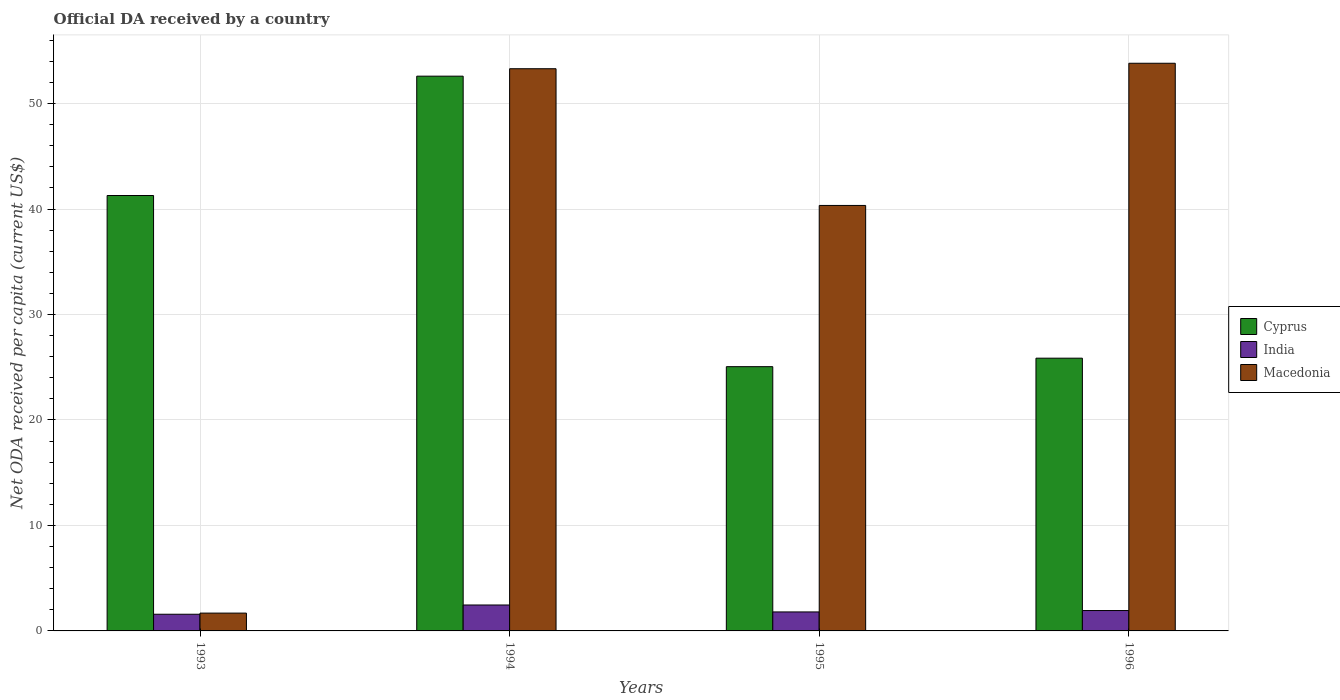How many different coloured bars are there?
Ensure brevity in your answer.  3. Are the number of bars on each tick of the X-axis equal?
Your response must be concise. Yes. How many bars are there on the 3rd tick from the right?
Offer a very short reply. 3. What is the label of the 1st group of bars from the left?
Provide a short and direct response. 1993. In how many cases, is the number of bars for a given year not equal to the number of legend labels?
Your answer should be compact. 0. What is the ODA received in in Macedonia in 1993?
Make the answer very short. 1.69. Across all years, what is the maximum ODA received in in Cyprus?
Ensure brevity in your answer.  52.59. Across all years, what is the minimum ODA received in in Macedonia?
Offer a very short reply. 1.69. What is the total ODA received in in India in the graph?
Your answer should be compact. 7.77. What is the difference between the ODA received in in Macedonia in 1994 and that in 1995?
Ensure brevity in your answer.  12.96. What is the difference between the ODA received in in India in 1993 and the ODA received in in Cyprus in 1996?
Your answer should be compact. -24.28. What is the average ODA received in in Macedonia per year?
Offer a terse response. 37.29. In the year 1994, what is the difference between the ODA received in in India and ODA received in in Cyprus?
Offer a terse response. -50.14. In how many years, is the ODA received in in Macedonia greater than 30 US$?
Provide a short and direct response. 3. What is the ratio of the ODA received in in India in 1993 to that in 1995?
Your response must be concise. 0.88. What is the difference between the highest and the second highest ODA received in in India?
Your answer should be compact. 0.53. What is the difference between the highest and the lowest ODA received in in Macedonia?
Offer a terse response. 52.13. In how many years, is the ODA received in in Cyprus greater than the average ODA received in in Cyprus taken over all years?
Your response must be concise. 2. Is the sum of the ODA received in in Cyprus in 1993 and 1996 greater than the maximum ODA received in in India across all years?
Ensure brevity in your answer.  Yes. What does the 1st bar from the left in 1995 represents?
Provide a succinct answer. Cyprus. Is it the case that in every year, the sum of the ODA received in in Macedonia and ODA received in in Cyprus is greater than the ODA received in in India?
Keep it short and to the point. Yes. How many years are there in the graph?
Keep it short and to the point. 4. Does the graph contain any zero values?
Your response must be concise. No. How many legend labels are there?
Your answer should be compact. 3. How are the legend labels stacked?
Offer a very short reply. Vertical. What is the title of the graph?
Provide a short and direct response. Official DA received by a country. Does "Argentina" appear as one of the legend labels in the graph?
Offer a very short reply. No. What is the label or title of the X-axis?
Make the answer very short. Years. What is the label or title of the Y-axis?
Your answer should be very brief. Net ODA received per capita (current US$). What is the Net ODA received per capita (current US$) of Cyprus in 1993?
Offer a terse response. 41.28. What is the Net ODA received per capita (current US$) of India in 1993?
Ensure brevity in your answer.  1.58. What is the Net ODA received per capita (current US$) of Macedonia in 1993?
Provide a succinct answer. 1.69. What is the Net ODA received per capita (current US$) of Cyprus in 1994?
Your response must be concise. 52.59. What is the Net ODA received per capita (current US$) of India in 1994?
Give a very brief answer. 2.46. What is the Net ODA received per capita (current US$) of Macedonia in 1994?
Your response must be concise. 53.3. What is the Net ODA received per capita (current US$) of Cyprus in 1995?
Provide a succinct answer. 25.05. What is the Net ODA received per capita (current US$) in India in 1995?
Your answer should be very brief. 1.8. What is the Net ODA received per capita (current US$) in Macedonia in 1995?
Your answer should be compact. 40.34. What is the Net ODA received per capita (current US$) in Cyprus in 1996?
Give a very brief answer. 25.86. What is the Net ODA received per capita (current US$) of India in 1996?
Ensure brevity in your answer.  1.93. What is the Net ODA received per capita (current US$) of Macedonia in 1996?
Give a very brief answer. 53.82. Across all years, what is the maximum Net ODA received per capita (current US$) in Cyprus?
Keep it short and to the point. 52.59. Across all years, what is the maximum Net ODA received per capita (current US$) of India?
Offer a terse response. 2.46. Across all years, what is the maximum Net ODA received per capita (current US$) of Macedonia?
Provide a short and direct response. 53.82. Across all years, what is the minimum Net ODA received per capita (current US$) of Cyprus?
Make the answer very short. 25.05. Across all years, what is the minimum Net ODA received per capita (current US$) of India?
Make the answer very short. 1.58. Across all years, what is the minimum Net ODA received per capita (current US$) of Macedonia?
Ensure brevity in your answer.  1.69. What is the total Net ODA received per capita (current US$) of Cyprus in the graph?
Provide a succinct answer. 144.78. What is the total Net ODA received per capita (current US$) in India in the graph?
Offer a terse response. 7.77. What is the total Net ODA received per capita (current US$) in Macedonia in the graph?
Offer a very short reply. 149.14. What is the difference between the Net ODA received per capita (current US$) of Cyprus in 1993 and that in 1994?
Provide a short and direct response. -11.31. What is the difference between the Net ODA received per capita (current US$) of India in 1993 and that in 1994?
Offer a terse response. -0.88. What is the difference between the Net ODA received per capita (current US$) in Macedonia in 1993 and that in 1994?
Provide a succinct answer. -51.61. What is the difference between the Net ODA received per capita (current US$) in Cyprus in 1993 and that in 1995?
Provide a short and direct response. 16.23. What is the difference between the Net ODA received per capita (current US$) in India in 1993 and that in 1995?
Ensure brevity in your answer.  -0.22. What is the difference between the Net ODA received per capita (current US$) of Macedonia in 1993 and that in 1995?
Make the answer very short. -38.65. What is the difference between the Net ODA received per capita (current US$) of Cyprus in 1993 and that in 1996?
Your answer should be compact. 15.42. What is the difference between the Net ODA received per capita (current US$) of India in 1993 and that in 1996?
Ensure brevity in your answer.  -0.35. What is the difference between the Net ODA received per capita (current US$) of Macedonia in 1993 and that in 1996?
Your response must be concise. -52.13. What is the difference between the Net ODA received per capita (current US$) in Cyprus in 1994 and that in 1995?
Ensure brevity in your answer.  27.54. What is the difference between the Net ODA received per capita (current US$) of India in 1994 and that in 1995?
Offer a terse response. 0.66. What is the difference between the Net ODA received per capita (current US$) in Macedonia in 1994 and that in 1995?
Give a very brief answer. 12.96. What is the difference between the Net ODA received per capita (current US$) in Cyprus in 1994 and that in 1996?
Your answer should be compact. 26.74. What is the difference between the Net ODA received per capita (current US$) in India in 1994 and that in 1996?
Provide a short and direct response. 0.53. What is the difference between the Net ODA received per capita (current US$) in Macedonia in 1994 and that in 1996?
Make the answer very short. -0.52. What is the difference between the Net ODA received per capita (current US$) of Cyprus in 1995 and that in 1996?
Keep it short and to the point. -0.8. What is the difference between the Net ODA received per capita (current US$) in India in 1995 and that in 1996?
Offer a very short reply. -0.13. What is the difference between the Net ODA received per capita (current US$) in Macedonia in 1995 and that in 1996?
Your answer should be compact. -13.48. What is the difference between the Net ODA received per capita (current US$) of Cyprus in 1993 and the Net ODA received per capita (current US$) of India in 1994?
Offer a very short reply. 38.82. What is the difference between the Net ODA received per capita (current US$) in Cyprus in 1993 and the Net ODA received per capita (current US$) in Macedonia in 1994?
Your answer should be very brief. -12.02. What is the difference between the Net ODA received per capita (current US$) in India in 1993 and the Net ODA received per capita (current US$) in Macedonia in 1994?
Offer a terse response. -51.72. What is the difference between the Net ODA received per capita (current US$) of Cyprus in 1993 and the Net ODA received per capita (current US$) of India in 1995?
Ensure brevity in your answer.  39.48. What is the difference between the Net ODA received per capita (current US$) of Cyprus in 1993 and the Net ODA received per capita (current US$) of Macedonia in 1995?
Your response must be concise. 0.94. What is the difference between the Net ODA received per capita (current US$) of India in 1993 and the Net ODA received per capita (current US$) of Macedonia in 1995?
Offer a terse response. -38.76. What is the difference between the Net ODA received per capita (current US$) of Cyprus in 1993 and the Net ODA received per capita (current US$) of India in 1996?
Offer a terse response. 39.35. What is the difference between the Net ODA received per capita (current US$) in Cyprus in 1993 and the Net ODA received per capita (current US$) in Macedonia in 1996?
Give a very brief answer. -12.54. What is the difference between the Net ODA received per capita (current US$) of India in 1993 and the Net ODA received per capita (current US$) of Macedonia in 1996?
Provide a succinct answer. -52.24. What is the difference between the Net ODA received per capita (current US$) of Cyprus in 1994 and the Net ODA received per capita (current US$) of India in 1995?
Make the answer very short. 50.79. What is the difference between the Net ODA received per capita (current US$) of Cyprus in 1994 and the Net ODA received per capita (current US$) of Macedonia in 1995?
Ensure brevity in your answer.  12.26. What is the difference between the Net ODA received per capita (current US$) in India in 1994 and the Net ODA received per capita (current US$) in Macedonia in 1995?
Give a very brief answer. -37.88. What is the difference between the Net ODA received per capita (current US$) of Cyprus in 1994 and the Net ODA received per capita (current US$) of India in 1996?
Your answer should be very brief. 50.66. What is the difference between the Net ODA received per capita (current US$) of Cyprus in 1994 and the Net ODA received per capita (current US$) of Macedonia in 1996?
Provide a short and direct response. -1.22. What is the difference between the Net ODA received per capita (current US$) of India in 1994 and the Net ODA received per capita (current US$) of Macedonia in 1996?
Make the answer very short. -51.36. What is the difference between the Net ODA received per capita (current US$) of Cyprus in 1995 and the Net ODA received per capita (current US$) of India in 1996?
Make the answer very short. 23.12. What is the difference between the Net ODA received per capita (current US$) in Cyprus in 1995 and the Net ODA received per capita (current US$) in Macedonia in 1996?
Provide a short and direct response. -28.76. What is the difference between the Net ODA received per capita (current US$) in India in 1995 and the Net ODA received per capita (current US$) in Macedonia in 1996?
Provide a succinct answer. -52.02. What is the average Net ODA received per capita (current US$) in Cyprus per year?
Offer a terse response. 36.2. What is the average Net ODA received per capita (current US$) in India per year?
Provide a succinct answer. 1.94. What is the average Net ODA received per capita (current US$) of Macedonia per year?
Your answer should be very brief. 37.29. In the year 1993, what is the difference between the Net ODA received per capita (current US$) of Cyprus and Net ODA received per capita (current US$) of India?
Your response must be concise. 39.7. In the year 1993, what is the difference between the Net ODA received per capita (current US$) in Cyprus and Net ODA received per capita (current US$) in Macedonia?
Keep it short and to the point. 39.59. In the year 1993, what is the difference between the Net ODA received per capita (current US$) of India and Net ODA received per capita (current US$) of Macedonia?
Offer a terse response. -0.11. In the year 1994, what is the difference between the Net ODA received per capita (current US$) in Cyprus and Net ODA received per capita (current US$) in India?
Offer a terse response. 50.14. In the year 1994, what is the difference between the Net ODA received per capita (current US$) of Cyprus and Net ODA received per capita (current US$) of Macedonia?
Keep it short and to the point. -0.7. In the year 1994, what is the difference between the Net ODA received per capita (current US$) of India and Net ODA received per capita (current US$) of Macedonia?
Your answer should be compact. -50.84. In the year 1995, what is the difference between the Net ODA received per capita (current US$) of Cyprus and Net ODA received per capita (current US$) of India?
Offer a terse response. 23.25. In the year 1995, what is the difference between the Net ODA received per capita (current US$) in Cyprus and Net ODA received per capita (current US$) in Macedonia?
Offer a very short reply. -15.28. In the year 1995, what is the difference between the Net ODA received per capita (current US$) of India and Net ODA received per capita (current US$) of Macedonia?
Your answer should be very brief. -38.54. In the year 1996, what is the difference between the Net ODA received per capita (current US$) in Cyprus and Net ODA received per capita (current US$) in India?
Your answer should be very brief. 23.93. In the year 1996, what is the difference between the Net ODA received per capita (current US$) in Cyprus and Net ODA received per capita (current US$) in Macedonia?
Provide a succinct answer. -27.96. In the year 1996, what is the difference between the Net ODA received per capita (current US$) in India and Net ODA received per capita (current US$) in Macedonia?
Offer a terse response. -51.88. What is the ratio of the Net ODA received per capita (current US$) of Cyprus in 1993 to that in 1994?
Provide a succinct answer. 0.78. What is the ratio of the Net ODA received per capita (current US$) in India in 1993 to that in 1994?
Give a very brief answer. 0.64. What is the ratio of the Net ODA received per capita (current US$) in Macedonia in 1993 to that in 1994?
Your answer should be compact. 0.03. What is the ratio of the Net ODA received per capita (current US$) of Cyprus in 1993 to that in 1995?
Offer a terse response. 1.65. What is the ratio of the Net ODA received per capita (current US$) in India in 1993 to that in 1995?
Give a very brief answer. 0.88. What is the ratio of the Net ODA received per capita (current US$) of Macedonia in 1993 to that in 1995?
Offer a very short reply. 0.04. What is the ratio of the Net ODA received per capita (current US$) of Cyprus in 1993 to that in 1996?
Ensure brevity in your answer.  1.6. What is the ratio of the Net ODA received per capita (current US$) in India in 1993 to that in 1996?
Make the answer very short. 0.82. What is the ratio of the Net ODA received per capita (current US$) of Macedonia in 1993 to that in 1996?
Keep it short and to the point. 0.03. What is the ratio of the Net ODA received per capita (current US$) in Cyprus in 1994 to that in 1995?
Provide a short and direct response. 2.1. What is the ratio of the Net ODA received per capita (current US$) of India in 1994 to that in 1995?
Make the answer very short. 1.37. What is the ratio of the Net ODA received per capita (current US$) of Macedonia in 1994 to that in 1995?
Make the answer very short. 1.32. What is the ratio of the Net ODA received per capita (current US$) of Cyprus in 1994 to that in 1996?
Provide a short and direct response. 2.03. What is the ratio of the Net ODA received per capita (current US$) of India in 1994 to that in 1996?
Your answer should be compact. 1.27. What is the ratio of the Net ODA received per capita (current US$) of Cyprus in 1995 to that in 1996?
Your answer should be compact. 0.97. What is the ratio of the Net ODA received per capita (current US$) in India in 1995 to that in 1996?
Offer a very short reply. 0.93. What is the ratio of the Net ODA received per capita (current US$) in Macedonia in 1995 to that in 1996?
Give a very brief answer. 0.75. What is the difference between the highest and the second highest Net ODA received per capita (current US$) in Cyprus?
Your answer should be compact. 11.31. What is the difference between the highest and the second highest Net ODA received per capita (current US$) in India?
Your response must be concise. 0.53. What is the difference between the highest and the second highest Net ODA received per capita (current US$) in Macedonia?
Provide a succinct answer. 0.52. What is the difference between the highest and the lowest Net ODA received per capita (current US$) of Cyprus?
Provide a short and direct response. 27.54. What is the difference between the highest and the lowest Net ODA received per capita (current US$) in India?
Ensure brevity in your answer.  0.88. What is the difference between the highest and the lowest Net ODA received per capita (current US$) in Macedonia?
Ensure brevity in your answer.  52.13. 